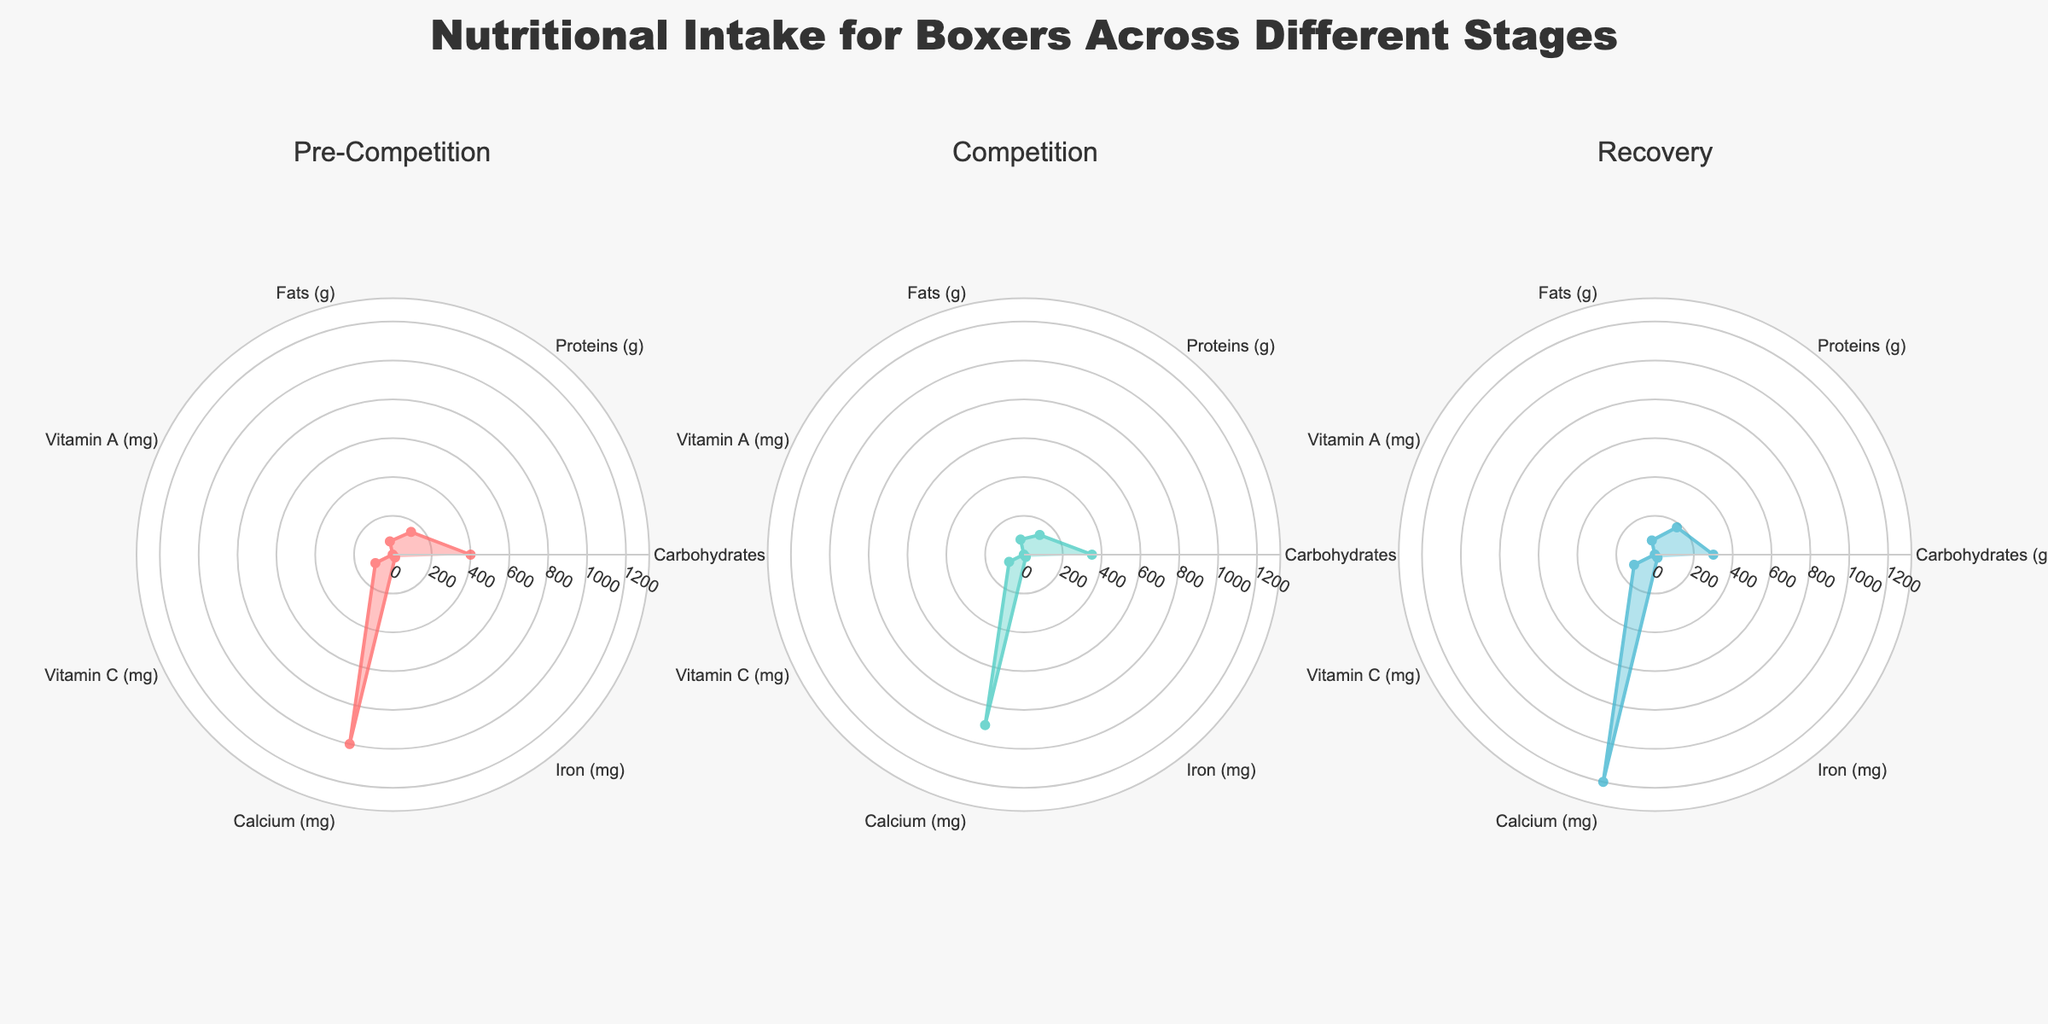What is the title of the figure? The title of the figure is displayed at the top, saying "Nutritional Intake for Boxers Across Different Stages".
Answer: Nutritional Intake for Boxers Across Different Stages How many subplots are there in the radar chart figure? There are three distinct radar charts, each representing a different stage: Pre-Competition, Competition, and Recovery.
Answer: 3 Which color represents the 'Competition' stage in the radar chart? Each stage uses a distinct color; the 'Competition' stage is represented by the second radar chart, filled with the color similar to blue-green or teal.
Answer: Blue-green/teal What is the total amount of Vitamin A across all stages? Add the Vitamin A amounts from each stage: Pre-Competition (1.5 mg), Competition (1.2 mg), Recovery (2 mg). This gives 1.5 + 1.2 + 2 = 4.7 mg.
Answer: 4.7 mg What is the difference in the amount of Carbohydrates between the Pre-Competition and Recovery stages? Identify the Carbohydrates (g) values for Pre-Competition (400 g) and Recovery (300 g). The difference is 400 - 300 = 100 g.
Answer: 100 g In which stage do boxers consume the highest amount of Iron? Compare the Iron values (mg) for each stage: Pre-Competition (18 mg), Competition (15 mg), Recovery (20 mg). Recovery has the highest amount of Iron at 20 mg.
Answer: Recovery Which stage has the lowest amount of Proteins? Compare the Protein values (g) for each stage: Pre-Competition (150 g), Competition (130 g), Recovery (180 g). Competition has the lowest amount of Proteins at 130 g.
Answer: Competition Which nutritional component has the biggest range across different stages? Calculate the range for each component (difference between maximum and minimum values): 
  - Carbohydrates: 400-300 = 100 g
  - Proteins: 180-130 = 50 g
  - Fats: 80-70 = 10 g
  - Vitamin A: 2-1.2 = 0.8 mg
  - Vitamin C: 120-85 = 35 mg
  - Calcium: 1200-900 = 300 mg
  - Iron: 20-15 = 5 mg. 
  The biggest range is for Calcium with a range of 300 mg.
Answer: Calcium During which stage do boxers consume the maximum amount of Vitamin C? Compare the Vitamin C values (mg) for each stage: Pre-Competition (100 mg), Competition (85 mg), Recovery (120 mg). The stage with the maximum Vitamin C intake is Recovery at 120 mg.
Answer: Recovery 